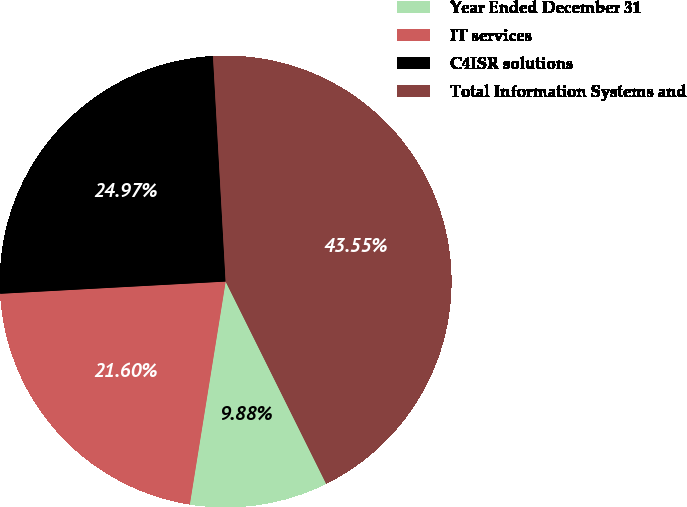<chart> <loc_0><loc_0><loc_500><loc_500><pie_chart><fcel>Year Ended December 31<fcel>IT services<fcel>C4ISR solutions<fcel>Total Information Systems and<nl><fcel>9.88%<fcel>21.6%<fcel>24.97%<fcel>43.55%<nl></chart> 